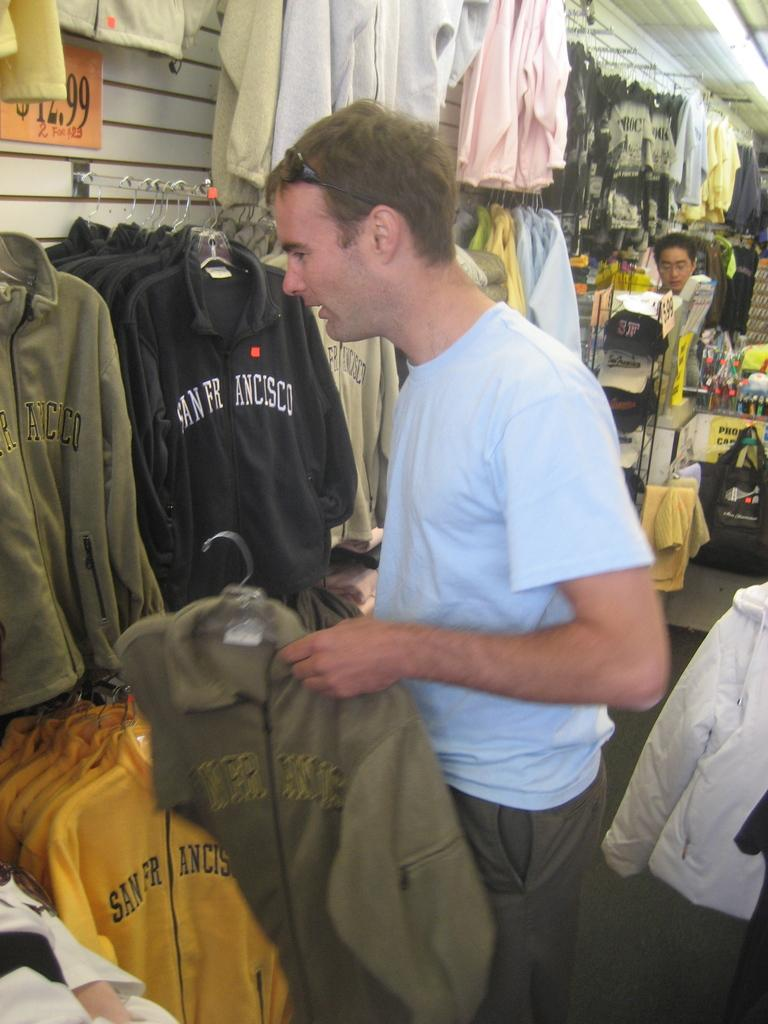<image>
Provide a brief description of the given image. A man looks through sweatshirts with San Francisco on the front in a store. 